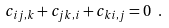<formula> <loc_0><loc_0><loc_500><loc_500>c _ { i j , k } + c _ { j k , i } + c _ { k i , j } = 0 \ .</formula> 